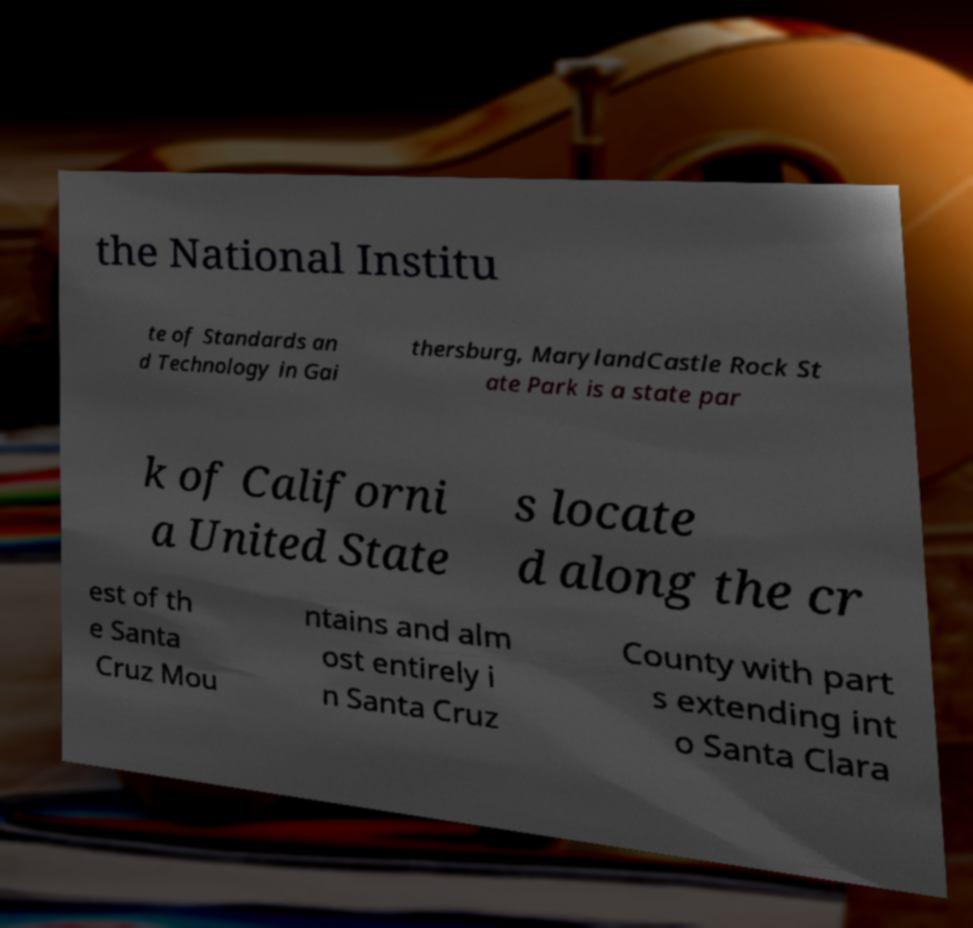There's text embedded in this image that I need extracted. Can you transcribe it verbatim? the National Institu te of Standards an d Technology in Gai thersburg, MarylandCastle Rock St ate Park is a state par k of Californi a United State s locate d along the cr est of th e Santa Cruz Mou ntains and alm ost entirely i n Santa Cruz County with part s extending int o Santa Clara 